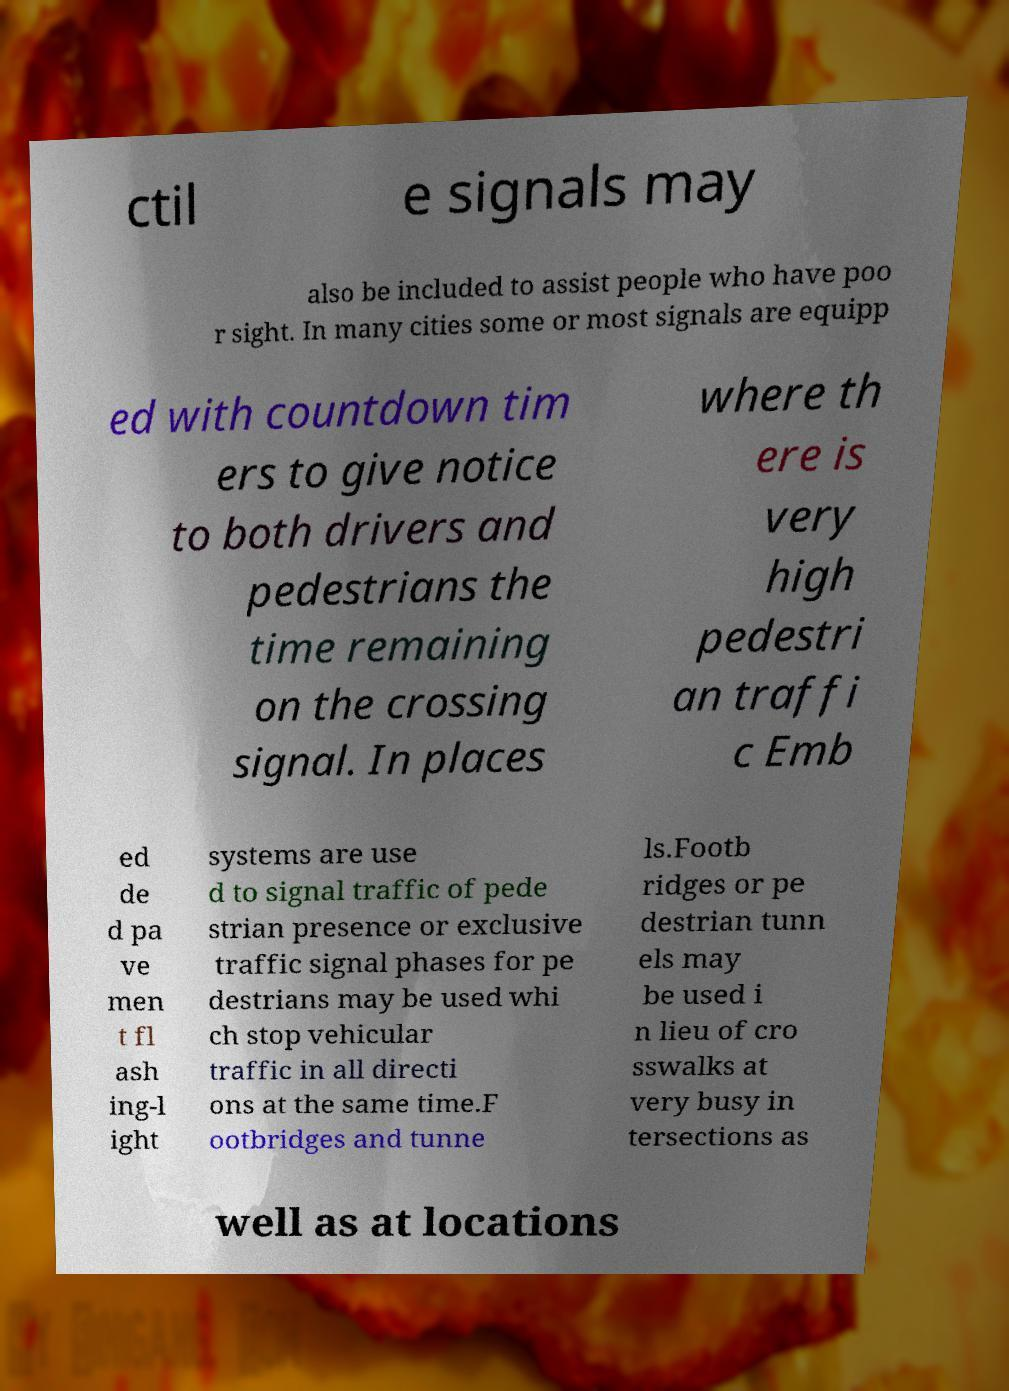Can you read and provide the text displayed in the image?This photo seems to have some interesting text. Can you extract and type it out for me? ctil e signals may also be included to assist people who have poo r sight. In many cities some or most signals are equipp ed with countdown tim ers to give notice to both drivers and pedestrians the time remaining on the crossing signal. In places where th ere is very high pedestri an traffi c Emb ed de d pa ve men t fl ash ing-l ight systems are use d to signal traffic of pede strian presence or exclusive traffic signal phases for pe destrians may be used whi ch stop vehicular traffic in all directi ons at the same time.F ootbridges and tunne ls.Footb ridges or pe destrian tunn els may be used i n lieu of cro sswalks at very busy in tersections as well as at locations 